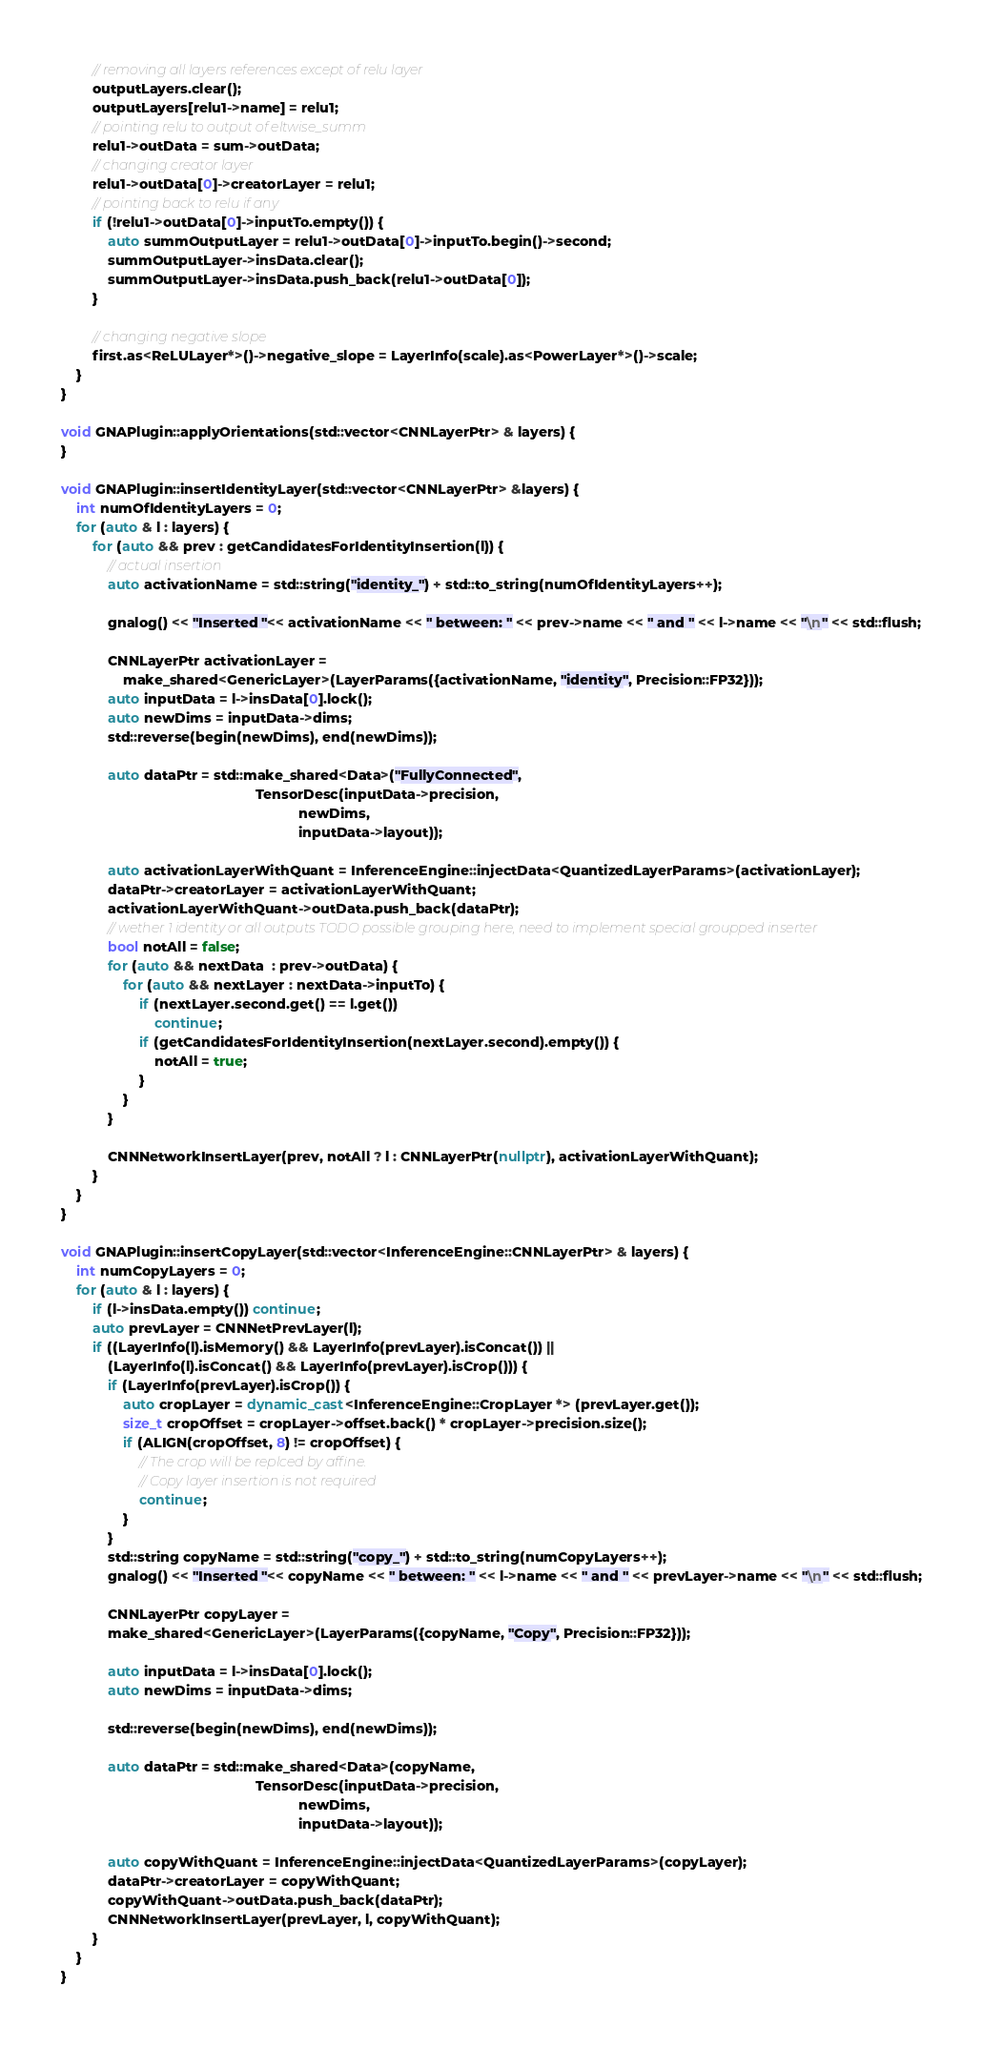<code> <loc_0><loc_0><loc_500><loc_500><_C++_>
        // removing all layers references except of relu layer
        outputLayers.clear();
        outputLayers[relu1->name] = relu1;
        // pointing relu to output of eltwise_summ
        relu1->outData = sum->outData;
        // changing creator layer
        relu1->outData[0]->creatorLayer = relu1;
        // pointing back to relu if any
        if (!relu1->outData[0]->inputTo.empty()) {
            auto summOutputLayer = relu1->outData[0]->inputTo.begin()->second;
            summOutputLayer->insData.clear();
            summOutputLayer->insData.push_back(relu1->outData[0]);
        }

        // changing negative slope
        first.as<ReLULayer*>()->negative_slope = LayerInfo(scale).as<PowerLayer*>()->scale;
    }
}

void GNAPlugin::applyOrientations(std::vector<CNNLayerPtr> & layers) {
}

void GNAPlugin::insertIdentityLayer(std::vector<CNNLayerPtr> &layers) {
    int numOfIdentityLayers = 0;
    for (auto & l : layers) {
        for (auto && prev : getCandidatesForIdentityInsertion(l)) {
            // actual insertion
            auto activationName = std::string("identity_") + std::to_string(numOfIdentityLayers++);

            gnalog() << "Inserted "<< activationName << " between: " << prev->name << " and " << l->name << "\n" << std::flush;

            CNNLayerPtr activationLayer =
                make_shared<GenericLayer>(LayerParams({activationName, "identity", Precision::FP32}));
            auto inputData = l->insData[0].lock();
            auto newDims = inputData->dims;
            std::reverse(begin(newDims), end(newDims));

            auto dataPtr = std::make_shared<Data>("FullyConnected",
                                                  TensorDesc(inputData->precision,
                                                             newDims,
                                                             inputData->layout));

            auto activationLayerWithQuant = InferenceEngine::injectData<QuantizedLayerParams>(activationLayer);
            dataPtr->creatorLayer = activationLayerWithQuant;
            activationLayerWithQuant->outData.push_back(dataPtr);
            // wether 1 identity or all outputs TODO possible grouping here, need to implement special groupped inserter
            bool notAll = false;
            for (auto && nextData  : prev->outData) {
                for (auto && nextLayer : nextData->inputTo) {
                    if (nextLayer.second.get() == l.get())
                        continue;
                    if (getCandidatesForIdentityInsertion(nextLayer.second).empty()) {
                        notAll = true;
                    }
                }
            }

            CNNNetworkInsertLayer(prev, notAll ? l : CNNLayerPtr(nullptr), activationLayerWithQuant);
        }
    }
}

void GNAPlugin::insertCopyLayer(std::vector<InferenceEngine::CNNLayerPtr> & layers) {
    int numCopyLayers = 0;
    for (auto & l : layers) {
        if (l->insData.empty()) continue;
        auto prevLayer = CNNNetPrevLayer(l);
        if ((LayerInfo(l).isMemory() && LayerInfo(prevLayer).isConcat()) ||
            (LayerInfo(l).isConcat() && LayerInfo(prevLayer).isCrop())) {
            if (LayerInfo(prevLayer).isCrop()) {
                auto cropLayer = dynamic_cast<InferenceEngine::CropLayer *> (prevLayer.get());
                size_t cropOffset = cropLayer->offset.back() * cropLayer->precision.size();
                if (ALIGN(cropOffset, 8) != cropOffset) {
                    // The crop will be replced by affine.
                    // Copy layer insertion is not required
                    continue;
                }
            }
            std::string copyName = std::string("copy_") + std::to_string(numCopyLayers++);
            gnalog() << "Inserted "<< copyName << " between: " << l->name << " and " << prevLayer->name << "\n" << std::flush;

            CNNLayerPtr copyLayer =
            make_shared<GenericLayer>(LayerParams({copyName, "Copy", Precision::FP32}));

            auto inputData = l->insData[0].lock();
            auto newDims = inputData->dims;

            std::reverse(begin(newDims), end(newDims));

            auto dataPtr = std::make_shared<Data>(copyName,
                                                  TensorDesc(inputData->precision,
                                                             newDims,
                                                             inputData->layout));

            auto copyWithQuant = InferenceEngine::injectData<QuantizedLayerParams>(copyLayer);
            dataPtr->creatorLayer = copyWithQuant;
            copyWithQuant->outData.push_back(dataPtr);
            CNNNetworkInsertLayer(prevLayer, l, copyWithQuant);
        }
    }
}
</code> 